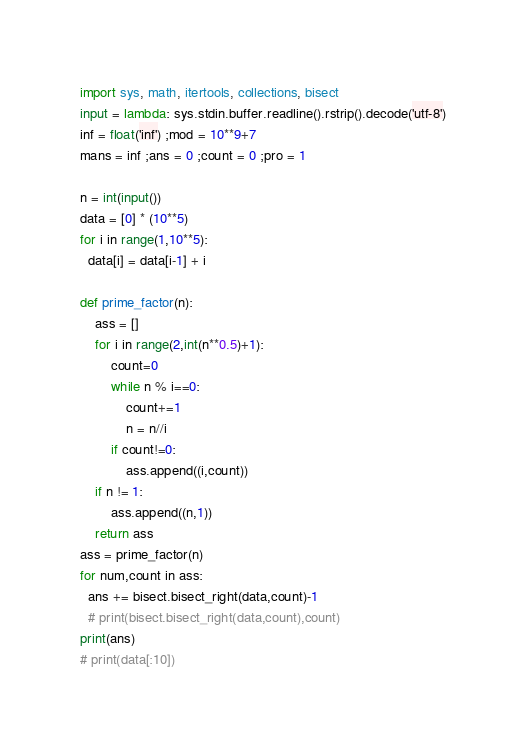Convert code to text. <code><loc_0><loc_0><loc_500><loc_500><_Python_>import sys, math, itertools, collections, bisect
input = lambda: sys.stdin.buffer.readline().rstrip().decode('utf-8')
inf = float('inf') ;mod = 10**9+7
mans = inf ;ans = 0 ;count = 0 ;pro = 1

n = int(input())
data = [0] * (10**5)
for i in range(1,10**5):
  data[i] = data[i-1] + i

def prime_factor(n):
    ass = []
    for i in range(2,int(n**0.5)+1):
        count=0
        while n % i==0:
            count+=1
            n = n//i
        if count!=0:
            ass.append((i,count))
    if n != 1:
        ass.append((n,1))
    return ass
ass = prime_factor(n)
for num,count in ass:
  ans += bisect.bisect_right(data,count)-1
  # print(bisect.bisect_right(data,count),count)
print(ans)
# print(data[:10])</code> 